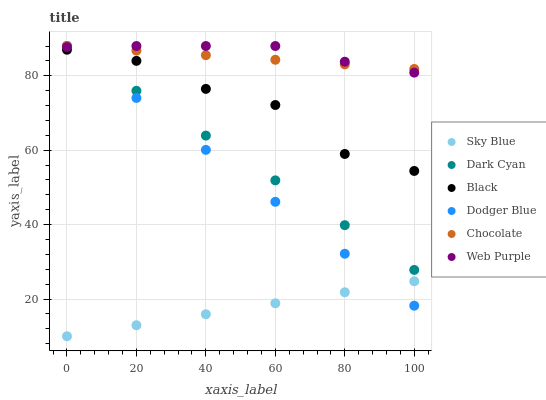Does Sky Blue have the minimum area under the curve?
Answer yes or no. Yes. Does Web Purple have the maximum area under the curve?
Answer yes or no. Yes. Does Chocolate have the minimum area under the curve?
Answer yes or no. No. Does Chocolate have the maximum area under the curve?
Answer yes or no. No. Is Sky Blue the smoothest?
Answer yes or no. Yes. Is Black the roughest?
Answer yes or no. Yes. Is Chocolate the smoothest?
Answer yes or no. No. Is Chocolate the roughest?
Answer yes or no. No. Does Sky Blue have the lowest value?
Answer yes or no. Yes. Does Web Purple have the lowest value?
Answer yes or no. No. Does Dark Cyan have the highest value?
Answer yes or no. Yes. Does Black have the highest value?
Answer yes or no. No. Is Black less than Chocolate?
Answer yes or no. Yes. Is Web Purple greater than Black?
Answer yes or no. Yes. Does Web Purple intersect Dark Cyan?
Answer yes or no. Yes. Is Web Purple less than Dark Cyan?
Answer yes or no. No. Is Web Purple greater than Dark Cyan?
Answer yes or no. No. Does Black intersect Chocolate?
Answer yes or no. No. 